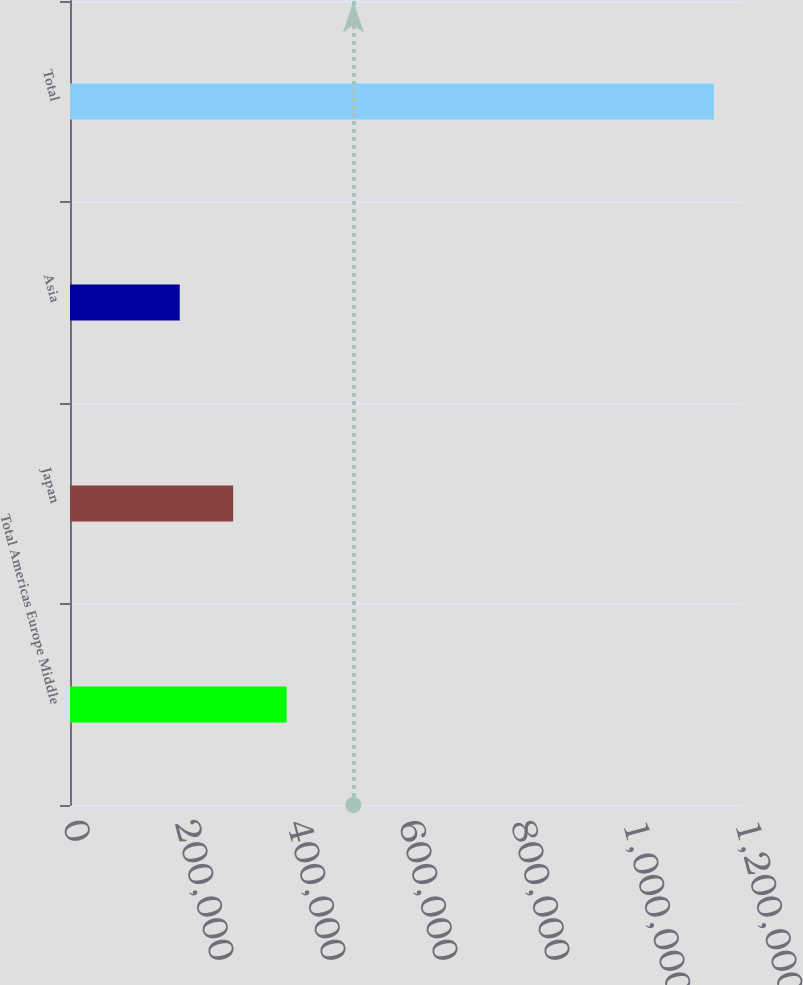Convert chart. <chart><loc_0><loc_0><loc_500><loc_500><bar_chart><fcel>Total Americas Europe Middle<fcel>Japan<fcel>Asia<fcel>Total<nl><fcel>386749<fcel>291363<fcel>195977<fcel>1.14984e+06<nl></chart> 